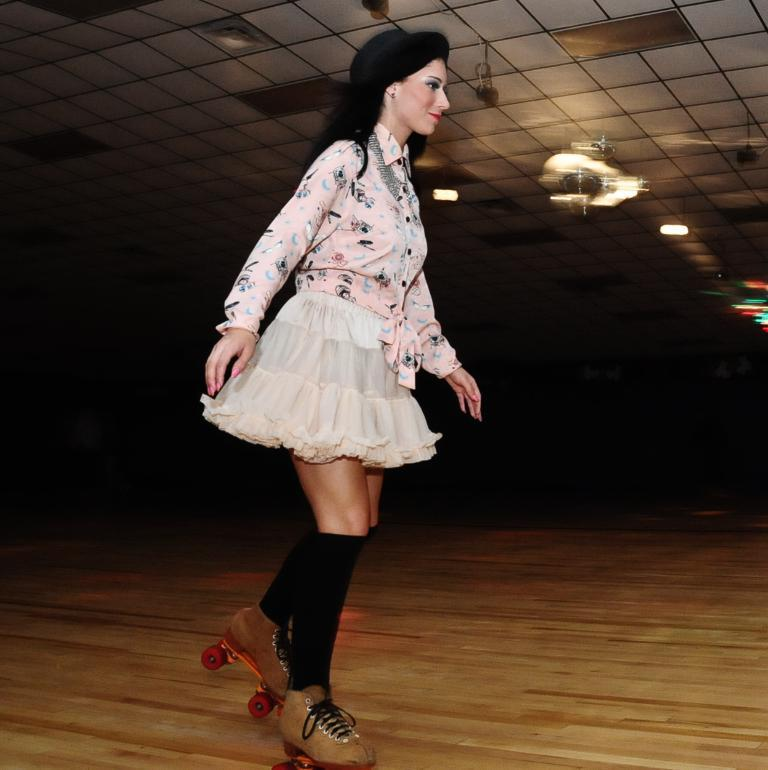Who is present in the image? There is a woman in the image. What is the woman doing in the image? The woman is standing on the floor. What type of shoes is the woman wearing? The woman is wearing skating shoes. What can be seen in the background of the image? There are electric lights visible in the background. Where are the electric lights located in relation to the roof? The electric lights are near the roof. What type of game is the woman playing with her brothers in the image? There is no game or brothers present in the image; it only features a woman standing on the floor wearing skating shoes. 